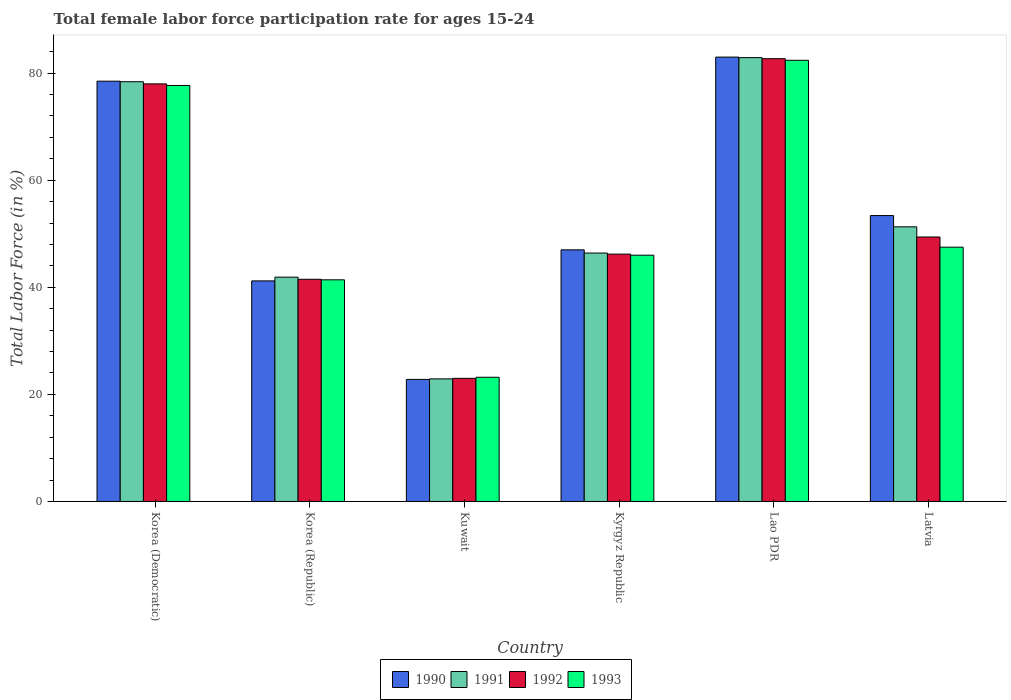How many different coloured bars are there?
Offer a terse response. 4. How many bars are there on the 2nd tick from the left?
Provide a succinct answer. 4. How many bars are there on the 1st tick from the right?
Give a very brief answer. 4. What is the label of the 3rd group of bars from the left?
Make the answer very short. Kuwait. What is the female labor force participation rate in 1991 in Korea (Republic)?
Provide a short and direct response. 41.9. Across all countries, what is the maximum female labor force participation rate in 1993?
Your answer should be compact. 82.4. Across all countries, what is the minimum female labor force participation rate in 1991?
Your answer should be compact. 22.9. In which country was the female labor force participation rate in 1990 maximum?
Make the answer very short. Lao PDR. In which country was the female labor force participation rate in 1991 minimum?
Offer a very short reply. Kuwait. What is the total female labor force participation rate in 1992 in the graph?
Provide a succinct answer. 320.8. What is the difference between the female labor force participation rate in 1991 in Kyrgyz Republic and that in Lao PDR?
Offer a terse response. -36.5. What is the difference between the female labor force participation rate in 1990 in Latvia and the female labor force participation rate in 1993 in Kuwait?
Keep it short and to the point. 30.2. What is the average female labor force participation rate in 1990 per country?
Offer a very short reply. 54.32. What is the difference between the female labor force participation rate of/in 1992 and female labor force participation rate of/in 1990 in Korea (Democratic)?
Offer a terse response. -0.5. In how many countries, is the female labor force participation rate in 1992 greater than 44 %?
Make the answer very short. 4. What is the ratio of the female labor force participation rate in 1993 in Korea (Democratic) to that in Kuwait?
Provide a succinct answer. 3.35. Is the female labor force participation rate in 1990 in Korea (Republic) less than that in Lao PDR?
Your response must be concise. Yes. Is the difference between the female labor force participation rate in 1992 in Korea (Democratic) and Kuwait greater than the difference between the female labor force participation rate in 1990 in Korea (Democratic) and Kuwait?
Provide a succinct answer. No. What is the difference between the highest and the second highest female labor force participation rate in 1991?
Provide a short and direct response. 31.6. What is the difference between the highest and the lowest female labor force participation rate in 1991?
Offer a terse response. 60. Is it the case that in every country, the sum of the female labor force participation rate in 1993 and female labor force participation rate in 1992 is greater than the sum of female labor force participation rate in 1991 and female labor force participation rate in 1990?
Keep it short and to the point. No. What does the 2nd bar from the left in Kuwait represents?
Your answer should be very brief. 1991. What does the 4th bar from the right in Kyrgyz Republic represents?
Make the answer very short. 1990. Are all the bars in the graph horizontal?
Ensure brevity in your answer.  No. What is the difference between two consecutive major ticks on the Y-axis?
Your answer should be very brief. 20. Does the graph contain any zero values?
Your answer should be compact. No. Does the graph contain grids?
Keep it short and to the point. No. Where does the legend appear in the graph?
Make the answer very short. Bottom center. How many legend labels are there?
Ensure brevity in your answer.  4. How are the legend labels stacked?
Your response must be concise. Horizontal. What is the title of the graph?
Offer a terse response. Total female labor force participation rate for ages 15-24. What is the label or title of the Y-axis?
Your response must be concise. Total Labor Force (in %). What is the Total Labor Force (in %) of 1990 in Korea (Democratic)?
Offer a terse response. 78.5. What is the Total Labor Force (in %) in 1991 in Korea (Democratic)?
Provide a short and direct response. 78.4. What is the Total Labor Force (in %) in 1993 in Korea (Democratic)?
Keep it short and to the point. 77.7. What is the Total Labor Force (in %) in 1990 in Korea (Republic)?
Provide a short and direct response. 41.2. What is the Total Labor Force (in %) of 1991 in Korea (Republic)?
Your answer should be compact. 41.9. What is the Total Labor Force (in %) of 1992 in Korea (Republic)?
Give a very brief answer. 41.5. What is the Total Labor Force (in %) in 1993 in Korea (Republic)?
Offer a very short reply. 41.4. What is the Total Labor Force (in %) of 1990 in Kuwait?
Make the answer very short. 22.8. What is the Total Labor Force (in %) of 1991 in Kuwait?
Ensure brevity in your answer.  22.9. What is the Total Labor Force (in %) of 1992 in Kuwait?
Ensure brevity in your answer.  23. What is the Total Labor Force (in %) of 1993 in Kuwait?
Provide a short and direct response. 23.2. What is the Total Labor Force (in %) in 1991 in Kyrgyz Republic?
Your response must be concise. 46.4. What is the Total Labor Force (in %) of 1992 in Kyrgyz Republic?
Keep it short and to the point. 46.2. What is the Total Labor Force (in %) of 1993 in Kyrgyz Republic?
Make the answer very short. 46. What is the Total Labor Force (in %) of 1990 in Lao PDR?
Provide a succinct answer. 83. What is the Total Labor Force (in %) of 1991 in Lao PDR?
Your response must be concise. 82.9. What is the Total Labor Force (in %) of 1992 in Lao PDR?
Your answer should be compact. 82.7. What is the Total Labor Force (in %) in 1993 in Lao PDR?
Provide a short and direct response. 82.4. What is the Total Labor Force (in %) of 1990 in Latvia?
Keep it short and to the point. 53.4. What is the Total Labor Force (in %) of 1991 in Latvia?
Your answer should be compact. 51.3. What is the Total Labor Force (in %) in 1992 in Latvia?
Your answer should be compact. 49.4. What is the Total Labor Force (in %) of 1993 in Latvia?
Provide a succinct answer. 47.5. Across all countries, what is the maximum Total Labor Force (in %) in 1991?
Offer a terse response. 82.9. Across all countries, what is the maximum Total Labor Force (in %) in 1992?
Give a very brief answer. 82.7. Across all countries, what is the maximum Total Labor Force (in %) in 1993?
Provide a short and direct response. 82.4. Across all countries, what is the minimum Total Labor Force (in %) of 1990?
Provide a short and direct response. 22.8. Across all countries, what is the minimum Total Labor Force (in %) of 1991?
Make the answer very short. 22.9. Across all countries, what is the minimum Total Labor Force (in %) of 1993?
Make the answer very short. 23.2. What is the total Total Labor Force (in %) of 1990 in the graph?
Keep it short and to the point. 325.9. What is the total Total Labor Force (in %) of 1991 in the graph?
Your answer should be very brief. 323.8. What is the total Total Labor Force (in %) of 1992 in the graph?
Your answer should be compact. 320.8. What is the total Total Labor Force (in %) in 1993 in the graph?
Your answer should be very brief. 318.2. What is the difference between the Total Labor Force (in %) in 1990 in Korea (Democratic) and that in Korea (Republic)?
Provide a short and direct response. 37.3. What is the difference between the Total Labor Force (in %) in 1991 in Korea (Democratic) and that in Korea (Republic)?
Offer a very short reply. 36.5. What is the difference between the Total Labor Force (in %) of 1992 in Korea (Democratic) and that in Korea (Republic)?
Provide a short and direct response. 36.5. What is the difference between the Total Labor Force (in %) of 1993 in Korea (Democratic) and that in Korea (Republic)?
Provide a succinct answer. 36.3. What is the difference between the Total Labor Force (in %) of 1990 in Korea (Democratic) and that in Kuwait?
Your response must be concise. 55.7. What is the difference between the Total Labor Force (in %) of 1991 in Korea (Democratic) and that in Kuwait?
Make the answer very short. 55.5. What is the difference between the Total Labor Force (in %) in 1993 in Korea (Democratic) and that in Kuwait?
Offer a terse response. 54.5. What is the difference between the Total Labor Force (in %) of 1990 in Korea (Democratic) and that in Kyrgyz Republic?
Offer a very short reply. 31.5. What is the difference between the Total Labor Force (in %) of 1992 in Korea (Democratic) and that in Kyrgyz Republic?
Give a very brief answer. 31.8. What is the difference between the Total Labor Force (in %) in 1993 in Korea (Democratic) and that in Kyrgyz Republic?
Make the answer very short. 31.7. What is the difference between the Total Labor Force (in %) in 1990 in Korea (Democratic) and that in Lao PDR?
Provide a short and direct response. -4.5. What is the difference between the Total Labor Force (in %) in 1991 in Korea (Democratic) and that in Lao PDR?
Your answer should be compact. -4.5. What is the difference between the Total Labor Force (in %) of 1990 in Korea (Democratic) and that in Latvia?
Ensure brevity in your answer.  25.1. What is the difference between the Total Labor Force (in %) of 1991 in Korea (Democratic) and that in Latvia?
Ensure brevity in your answer.  27.1. What is the difference between the Total Labor Force (in %) of 1992 in Korea (Democratic) and that in Latvia?
Keep it short and to the point. 28.6. What is the difference between the Total Labor Force (in %) in 1993 in Korea (Democratic) and that in Latvia?
Offer a terse response. 30.2. What is the difference between the Total Labor Force (in %) in 1990 in Korea (Republic) and that in Kuwait?
Your answer should be compact. 18.4. What is the difference between the Total Labor Force (in %) in 1991 in Korea (Republic) and that in Kuwait?
Offer a very short reply. 19. What is the difference between the Total Labor Force (in %) of 1992 in Korea (Republic) and that in Kuwait?
Give a very brief answer. 18.5. What is the difference between the Total Labor Force (in %) in 1990 in Korea (Republic) and that in Kyrgyz Republic?
Provide a short and direct response. -5.8. What is the difference between the Total Labor Force (in %) of 1991 in Korea (Republic) and that in Kyrgyz Republic?
Give a very brief answer. -4.5. What is the difference between the Total Labor Force (in %) in 1993 in Korea (Republic) and that in Kyrgyz Republic?
Provide a short and direct response. -4.6. What is the difference between the Total Labor Force (in %) of 1990 in Korea (Republic) and that in Lao PDR?
Provide a succinct answer. -41.8. What is the difference between the Total Labor Force (in %) in 1991 in Korea (Republic) and that in Lao PDR?
Provide a short and direct response. -41. What is the difference between the Total Labor Force (in %) of 1992 in Korea (Republic) and that in Lao PDR?
Offer a terse response. -41.2. What is the difference between the Total Labor Force (in %) of 1993 in Korea (Republic) and that in Lao PDR?
Ensure brevity in your answer.  -41. What is the difference between the Total Labor Force (in %) in 1990 in Korea (Republic) and that in Latvia?
Your response must be concise. -12.2. What is the difference between the Total Labor Force (in %) of 1991 in Korea (Republic) and that in Latvia?
Ensure brevity in your answer.  -9.4. What is the difference between the Total Labor Force (in %) of 1992 in Korea (Republic) and that in Latvia?
Your answer should be compact. -7.9. What is the difference between the Total Labor Force (in %) in 1990 in Kuwait and that in Kyrgyz Republic?
Give a very brief answer. -24.2. What is the difference between the Total Labor Force (in %) in 1991 in Kuwait and that in Kyrgyz Republic?
Ensure brevity in your answer.  -23.5. What is the difference between the Total Labor Force (in %) of 1992 in Kuwait and that in Kyrgyz Republic?
Keep it short and to the point. -23.2. What is the difference between the Total Labor Force (in %) in 1993 in Kuwait and that in Kyrgyz Republic?
Ensure brevity in your answer.  -22.8. What is the difference between the Total Labor Force (in %) in 1990 in Kuwait and that in Lao PDR?
Provide a short and direct response. -60.2. What is the difference between the Total Labor Force (in %) of 1991 in Kuwait and that in Lao PDR?
Your answer should be very brief. -60. What is the difference between the Total Labor Force (in %) in 1992 in Kuwait and that in Lao PDR?
Your answer should be very brief. -59.7. What is the difference between the Total Labor Force (in %) in 1993 in Kuwait and that in Lao PDR?
Offer a very short reply. -59.2. What is the difference between the Total Labor Force (in %) of 1990 in Kuwait and that in Latvia?
Make the answer very short. -30.6. What is the difference between the Total Labor Force (in %) in 1991 in Kuwait and that in Latvia?
Your response must be concise. -28.4. What is the difference between the Total Labor Force (in %) of 1992 in Kuwait and that in Latvia?
Ensure brevity in your answer.  -26.4. What is the difference between the Total Labor Force (in %) of 1993 in Kuwait and that in Latvia?
Provide a short and direct response. -24.3. What is the difference between the Total Labor Force (in %) of 1990 in Kyrgyz Republic and that in Lao PDR?
Your answer should be compact. -36. What is the difference between the Total Labor Force (in %) of 1991 in Kyrgyz Republic and that in Lao PDR?
Make the answer very short. -36.5. What is the difference between the Total Labor Force (in %) of 1992 in Kyrgyz Republic and that in Lao PDR?
Your answer should be compact. -36.5. What is the difference between the Total Labor Force (in %) in 1993 in Kyrgyz Republic and that in Lao PDR?
Your answer should be very brief. -36.4. What is the difference between the Total Labor Force (in %) of 1990 in Kyrgyz Republic and that in Latvia?
Give a very brief answer. -6.4. What is the difference between the Total Labor Force (in %) in 1991 in Kyrgyz Republic and that in Latvia?
Provide a succinct answer. -4.9. What is the difference between the Total Labor Force (in %) in 1992 in Kyrgyz Republic and that in Latvia?
Provide a short and direct response. -3.2. What is the difference between the Total Labor Force (in %) of 1993 in Kyrgyz Republic and that in Latvia?
Your response must be concise. -1.5. What is the difference between the Total Labor Force (in %) of 1990 in Lao PDR and that in Latvia?
Your answer should be very brief. 29.6. What is the difference between the Total Labor Force (in %) in 1991 in Lao PDR and that in Latvia?
Give a very brief answer. 31.6. What is the difference between the Total Labor Force (in %) of 1992 in Lao PDR and that in Latvia?
Your answer should be compact. 33.3. What is the difference between the Total Labor Force (in %) in 1993 in Lao PDR and that in Latvia?
Make the answer very short. 34.9. What is the difference between the Total Labor Force (in %) in 1990 in Korea (Democratic) and the Total Labor Force (in %) in 1991 in Korea (Republic)?
Make the answer very short. 36.6. What is the difference between the Total Labor Force (in %) in 1990 in Korea (Democratic) and the Total Labor Force (in %) in 1992 in Korea (Republic)?
Offer a terse response. 37. What is the difference between the Total Labor Force (in %) of 1990 in Korea (Democratic) and the Total Labor Force (in %) of 1993 in Korea (Republic)?
Your answer should be very brief. 37.1. What is the difference between the Total Labor Force (in %) in 1991 in Korea (Democratic) and the Total Labor Force (in %) in 1992 in Korea (Republic)?
Make the answer very short. 36.9. What is the difference between the Total Labor Force (in %) in 1991 in Korea (Democratic) and the Total Labor Force (in %) in 1993 in Korea (Republic)?
Your answer should be compact. 37. What is the difference between the Total Labor Force (in %) in 1992 in Korea (Democratic) and the Total Labor Force (in %) in 1993 in Korea (Republic)?
Your answer should be compact. 36.6. What is the difference between the Total Labor Force (in %) in 1990 in Korea (Democratic) and the Total Labor Force (in %) in 1991 in Kuwait?
Your response must be concise. 55.6. What is the difference between the Total Labor Force (in %) in 1990 in Korea (Democratic) and the Total Labor Force (in %) in 1992 in Kuwait?
Your answer should be very brief. 55.5. What is the difference between the Total Labor Force (in %) in 1990 in Korea (Democratic) and the Total Labor Force (in %) in 1993 in Kuwait?
Ensure brevity in your answer.  55.3. What is the difference between the Total Labor Force (in %) of 1991 in Korea (Democratic) and the Total Labor Force (in %) of 1992 in Kuwait?
Provide a succinct answer. 55.4. What is the difference between the Total Labor Force (in %) of 1991 in Korea (Democratic) and the Total Labor Force (in %) of 1993 in Kuwait?
Provide a succinct answer. 55.2. What is the difference between the Total Labor Force (in %) in 1992 in Korea (Democratic) and the Total Labor Force (in %) in 1993 in Kuwait?
Provide a succinct answer. 54.8. What is the difference between the Total Labor Force (in %) in 1990 in Korea (Democratic) and the Total Labor Force (in %) in 1991 in Kyrgyz Republic?
Make the answer very short. 32.1. What is the difference between the Total Labor Force (in %) in 1990 in Korea (Democratic) and the Total Labor Force (in %) in 1992 in Kyrgyz Republic?
Provide a short and direct response. 32.3. What is the difference between the Total Labor Force (in %) in 1990 in Korea (Democratic) and the Total Labor Force (in %) in 1993 in Kyrgyz Republic?
Ensure brevity in your answer.  32.5. What is the difference between the Total Labor Force (in %) in 1991 in Korea (Democratic) and the Total Labor Force (in %) in 1992 in Kyrgyz Republic?
Give a very brief answer. 32.2. What is the difference between the Total Labor Force (in %) in 1991 in Korea (Democratic) and the Total Labor Force (in %) in 1993 in Kyrgyz Republic?
Give a very brief answer. 32.4. What is the difference between the Total Labor Force (in %) in 1992 in Korea (Democratic) and the Total Labor Force (in %) in 1993 in Kyrgyz Republic?
Ensure brevity in your answer.  32. What is the difference between the Total Labor Force (in %) in 1990 in Korea (Democratic) and the Total Labor Force (in %) in 1991 in Lao PDR?
Make the answer very short. -4.4. What is the difference between the Total Labor Force (in %) in 1990 in Korea (Democratic) and the Total Labor Force (in %) in 1992 in Lao PDR?
Offer a very short reply. -4.2. What is the difference between the Total Labor Force (in %) of 1990 in Korea (Democratic) and the Total Labor Force (in %) of 1993 in Lao PDR?
Give a very brief answer. -3.9. What is the difference between the Total Labor Force (in %) in 1991 in Korea (Democratic) and the Total Labor Force (in %) in 1992 in Lao PDR?
Offer a terse response. -4.3. What is the difference between the Total Labor Force (in %) of 1990 in Korea (Democratic) and the Total Labor Force (in %) of 1991 in Latvia?
Keep it short and to the point. 27.2. What is the difference between the Total Labor Force (in %) in 1990 in Korea (Democratic) and the Total Labor Force (in %) in 1992 in Latvia?
Keep it short and to the point. 29.1. What is the difference between the Total Labor Force (in %) in 1991 in Korea (Democratic) and the Total Labor Force (in %) in 1992 in Latvia?
Give a very brief answer. 29. What is the difference between the Total Labor Force (in %) of 1991 in Korea (Democratic) and the Total Labor Force (in %) of 1993 in Latvia?
Provide a succinct answer. 30.9. What is the difference between the Total Labor Force (in %) of 1992 in Korea (Democratic) and the Total Labor Force (in %) of 1993 in Latvia?
Provide a succinct answer. 30.5. What is the difference between the Total Labor Force (in %) of 1990 in Korea (Republic) and the Total Labor Force (in %) of 1991 in Kuwait?
Provide a short and direct response. 18.3. What is the difference between the Total Labor Force (in %) in 1990 in Korea (Republic) and the Total Labor Force (in %) in 1992 in Kuwait?
Provide a short and direct response. 18.2. What is the difference between the Total Labor Force (in %) of 1991 in Korea (Republic) and the Total Labor Force (in %) of 1993 in Kuwait?
Ensure brevity in your answer.  18.7. What is the difference between the Total Labor Force (in %) of 1990 in Korea (Republic) and the Total Labor Force (in %) of 1993 in Kyrgyz Republic?
Offer a very short reply. -4.8. What is the difference between the Total Labor Force (in %) in 1991 in Korea (Republic) and the Total Labor Force (in %) in 1993 in Kyrgyz Republic?
Ensure brevity in your answer.  -4.1. What is the difference between the Total Labor Force (in %) in 1990 in Korea (Republic) and the Total Labor Force (in %) in 1991 in Lao PDR?
Offer a terse response. -41.7. What is the difference between the Total Labor Force (in %) in 1990 in Korea (Republic) and the Total Labor Force (in %) in 1992 in Lao PDR?
Make the answer very short. -41.5. What is the difference between the Total Labor Force (in %) of 1990 in Korea (Republic) and the Total Labor Force (in %) of 1993 in Lao PDR?
Your response must be concise. -41.2. What is the difference between the Total Labor Force (in %) in 1991 in Korea (Republic) and the Total Labor Force (in %) in 1992 in Lao PDR?
Provide a short and direct response. -40.8. What is the difference between the Total Labor Force (in %) in 1991 in Korea (Republic) and the Total Labor Force (in %) in 1993 in Lao PDR?
Offer a terse response. -40.5. What is the difference between the Total Labor Force (in %) of 1992 in Korea (Republic) and the Total Labor Force (in %) of 1993 in Lao PDR?
Provide a succinct answer. -40.9. What is the difference between the Total Labor Force (in %) of 1990 in Korea (Republic) and the Total Labor Force (in %) of 1993 in Latvia?
Offer a very short reply. -6.3. What is the difference between the Total Labor Force (in %) in 1991 in Korea (Republic) and the Total Labor Force (in %) in 1992 in Latvia?
Your response must be concise. -7.5. What is the difference between the Total Labor Force (in %) of 1991 in Korea (Republic) and the Total Labor Force (in %) of 1993 in Latvia?
Your response must be concise. -5.6. What is the difference between the Total Labor Force (in %) in 1992 in Korea (Republic) and the Total Labor Force (in %) in 1993 in Latvia?
Give a very brief answer. -6. What is the difference between the Total Labor Force (in %) of 1990 in Kuwait and the Total Labor Force (in %) of 1991 in Kyrgyz Republic?
Provide a short and direct response. -23.6. What is the difference between the Total Labor Force (in %) in 1990 in Kuwait and the Total Labor Force (in %) in 1992 in Kyrgyz Republic?
Your answer should be compact. -23.4. What is the difference between the Total Labor Force (in %) of 1990 in Kuwait and the Total Labor Force (in %) of 1993 in Kyrgyz Republic?
Ensure brevity in your answer.  -23.2. What is the difference between the Total Labor Force (in %) of 1991 in Kuwait and the Total Labor Force (in %) of 1992 in Kyrgyz Republic?
Keep it short and to the point. -23.3. What is the difference between the Total Labor Force (in %) of 1991 in Kuwait and the Total Labor Force (in %) of 1993 in Kyrgyz Republic?
Your response must be concise. -23.1. What is the difference between the Total Labor Force (in %) in 1990 in Kuwait and the Total Labor Force (in %) in 1991 in Lao PDR?
Offer a terse response. -60.1. What is the difference between the Total Labor Force (in %) in 1990 in Kuwait and the Total Labor Force (in %) in 1992 in Lao PDR?
Give a very brief answer. -59.9. What is the difference between the Total Labor Force (in %) of 1990 in Kuwait and the Total Labor Force (in %) of 1993 in Lao PDR?
Give a very brief answer. -59.6. What is the difference between the Total Labor Force (in %) in 1991 in Kuwait and the Total Labor Force (in %) in 1992 in Lao PDR?
Provide a short and direct response. -59.8. What is the difference between the Total Labor Force (in %) in 1991 in Kuwait and the Total Labor Force (in %) in 1993 in Lao PDR?
Ensure brevity in your answer.  -59.5. What is the difference between the Total Labor Force (in %) of 1992 in Kuwait and the Total Labor Force (in %) of 1993 in Lao PDR?
Make the answer very short. -59.4. What is the difference between the Total Labor Force (in %) of 1990 in Kuwait and the Total Labor Force (in %) of 1991 in Latvia?
Your answer should be very brief. -28.5. What is the difference between the Total Labor Force (in %) in 1990 in Kuwait and the Total Labor Force (in %) in 1992 in Latvia?
Your answer should be very brief. -26.6. What is the difference between the Total Labor Force (in %) in 1990 in Kuwait and the Total Labor Force (in %) in 1993 in Latvia?
Offer a terse response. -24.7. What is the difference between the Total Labor Force (in %) in 1991 in Kuwait and the Total Labor Force (in %) in 1992 in Latvia?
Your answer should be very brief. -26.5. What is the difference between the Total Labor Force (in %) of 1991 in Kuwait and the Total Labor Force (in %) of 1993 in Latvia?
Keep it short and to the point. -24.6. What is the difference between the Total Labor Force (in %) in 1992 in Kuwait and the Total Labor Force (in %) in 1993 in Latvia?
Make the answer very short. -24.5. What is the difference between the Total Labor Force (in %) of 1990 in Kyrgyz Republic and the Total Labor Force (in %) of 1991 in Lao PDR?
Provide a succinct answer. -35.9. What is the difference between the Total Labor Force (in %) in 1990 in Kyrgyz Republic and the Total Labor Force (in %) in 1992 in Lao PDR?
Provide a short and direct response. -35.7. What is the difference between the Total Labor Force (in %) of 1990 in Kyrgyz Republic and the Total Labor Force (in %) of 1993 in Lao PDR?
Provide a succinct answer. -35.4. What is the difference between the Total Labor Force (in %) in 1991 in Kyrgyz Republic and the Total Labor Force (in %) in 1992 in Lao PDR?
Offer a very short reply. -36.3. What is the difference between the Total Labor Force (in %) of 1991 in Kyrgyz Republic and the Total Labor Force (in %) of 1993 in Lao PDR?
Your response must be concise. -36. What is the difference between the Total Labor Force (in %) in 1992 in Kyrgyz Republic and the Total Labor Force (in %) in 1993 in Lao PDR?
Offer a terse response. -36.2. What is the difference between the Total Labor Force (in %) of 1990 in Kyrgyz Republic and the Total Labor Force (in %) of 1991 in Latvia?
Make the answer very short. -4.3. What is the difference between the Total Labor Force (in %) in 1990 in Kyrgyz Republic and the Total Labor Force (in %) in 1993 in Latvia?
Provide a short and direct response. -0.5. What is the difference between the Total Labor Force (in %) in 1991 in Kyrgyz Republic and the Total Labor Force (in %) in 1992 in Latvia?
Your answer should be very brief. -3. What is the difference between the Total Labor Force (in %) of 1991 in Kyrgyz Republic and the Total Labor Force (in %) of 1993 in Latvia?
Offer a terse response. -1.1. What is the difference between the Total Labor Force (in %) of 1992 in Kyrgyz Republic and the Total Labor Force (in %) of 1993 in Latvia?
Your response must be concise. -1.3. What is the difference between the Total Labor Force (in %) in 1990 in Lao PDR and the Total Labor Force (in %) in 1991 in Latvia?
Ensure brevity in your answer.  31.7. What is the difference between the Total Labor Force (in %) of 1990 in Lao PDR and the Total Labor Force (in %) of 1992 in Latvia?
Ensure brevity in your answer.  33.6. What is the difference between the Total Labor Force (in %) in 1990 in Lao PDR and the Total Labor Force (in %) in 1993 in Latvia?
Make the answer very short. 35.5. What is the difference between the Total Labor Force (in %) of 1991 in Lao PDR and the Total Labor Force (in %) of 1992 in Latvia?
Your response must be concise. 33.5. What is the difference between the Total Labor Force (in %) of 1991 in Lao PDR and the Total Labor Force (in %) of 1993 in Latvia?
Keep it short and to the point. 35.4. What is the difference between the Total Labor Force (in %) of 1992 in Lao PDR and the Total Labor Force (in %) of 1993 in Latvia?
Your answer should be very brief. 35.2. What is the average Total Labor Force (in %) in 1990 per country?
Make the answer very short. 54.32. What is the average Total Labor Force (in %) in 1991 per country?
Ensure brevity in your answer.  53.97. What is the average Total Labor Force (in %) of 1992 per country?
Provide a succinct answer. 53.47. What is the average Total Labor Force (in %) in 1993 per country?
Ensure brevity in your answer.  53.03. What is the difference between the Total Labor Force (in %) in 1990 and Total Labor Force (in %) in 1992 in Korea (Democratic)?
Your answer should be very brief. 0.5. What is the difference between the Total Labor Force (in %) in 1991 and Total Labor Force (in %) in 1993 in Korea (Democratic)?
Offer a very short reply. 0.7. What is the difference between the Total Labor Force (in %) of 1992 and Total Labor Force (in %) of 1993 in Korea (Democratic)?
Give a very brief answer. 0.3. What is the difference between the Total Labor Force (in %) of 1990 and Total Labor Force (in %) of 1993 in Korea (Republic)?
Offer a very short reply. -0.2. What is the difference between the Total Labor Force (in %) in 1991 and Total Labor Force (in %) in 1993 in Korea (Republic)?
Offer a terse response. 0.5. What is the difference between the Total Labor Force (in %) of 1990 and Total Labor Force (in %) of 1992 in Kuwait?
Offer a terse response. -0.2. What is the difference between the Total Labor Force (in %) in 1990 and Total Labor Force (in %) in 1993 in Kuwait?
Give a very brief answer. -0.4. What is the difference between the Total Labor Force (in %) of 1991 and Total Labor Force (in %) of 1992 in Kuwait?
Give a very brief answer. -0.1. What is the difference between the Total Labor Force (in %) of 1991 and Total Labor Force (in %) of 1993 in Kuwait?
Your answer should be compact. -0.3. What is the difference between the Total Labor Force (in %) in 1992 and Total Labor Force (in %) in 1993 in Kuwait?
Offer a terse response. -0.2. What is the difference between the Total Labor Force (in %) in 1990 and Total Labor Force (in %) in 1993 in Kyrgyz Republic?
Provide a short and direct response. 1. What is the difference between the Total Labor Force (in %) in 1991 and Total Labor Force (in %) in 1993 in Kyrgyz Republic?
Ensure brevity in your answer.  0.4. What is the difference between the Total Labor Force (in %) of 1990 and Total Labor Force (in %) of 1991 in Lao PDR?
Give a very brief answer. 0.1. What is the difference between the Total Labor Force (in %) of 1990 and Total Labor Force (in %) of 1993 in Lao PDR?
Your answer should be very brief. 0.6. What is the difference between the Total Labor Force (in %) of 1991 and Total Labor Force (in %) of 1993 in Lao PDR?
Your response must be concise. 0.5. What is the difference between the Total Labor Force (in %) in 1990 and Total Labor Force (in %) in 1991 in Latvia?
Ensure brevity in your answer.  2.1. What is the difference between the Total Labor Force (in %) of 1990 and Total Labor Force (in %) of 1992 in Latvia?
Offer a very short reply. 4. What is the difference between the Total Labor Force (in %) of 1990 and Total Labor Force (in %) of 1993 in Latvia?
Ensure brevity in your answer.  5.9. What is the difference between the Total Labor Force (in %) of 1991 and Total Labor Force (in %) of 1993 in Latvia?
Keep it short and to the point. 3.8. What is the ratio of the Total Labor Force (in %) in 1990 in Korea (Democratic) to that in Korea (Republic)?
Offer a terse response. 1.91. What is the ratio of the Total Labor Force (in %) of 1991 in Korea (Democratic) to that in Korea (Republic)?
Give a very brief answer. 1.87. What is the ratio of the Total Labor Force (in %) of 1992 in Korea (Democratic) to that in Korea (Republic)?
Offer a terse response. 1.88. What is the ratio of the Total Labor Force (in %) of 1993 in Korea (Democratic) to that in Korea (Republic)?
Provide a short and direct response. 1.88. What is the ratio of the Total Labor Force (in %) of 1990 in Korea (Democratic) to that in Kuwait?
Keep it short and to the point. 3.44. What is the ratio of the Total Labor Force (in %) in 1991 in Korea (Democratic) to that in Kuwait?
Give a very brief answer. 3.42. What is the ratio of the Total Labor Force (in %) of 1992 in Korea (Democratic) to that in Kuwait?
Make the answer very short. 3.39. What is the ratio of the Total Labor Force (in %) in 1993 in Korea (Democratic) to that in Kuwait?
Offer a terse response. 3.35. What is the ratio of the Total Labor Force (in %) in 1990 in Korea (Democratic) to that in Kyrgyz Republic?
Offer a very short reply. 1.67. What is the ratio of the Total Labor Force (in %) in 1991 in Korea (Democratic) to that in Kyrgyz Republic?
Your answer should be compact. 1.69. What is the ratio of the Total Labor Force (in %) in 1992 in Korea (Democratic) to that in Kyrgyz Republic?
Your response must be concise. 1.69. What is the ratio of the Total Labor Force (in %) of 1993 in Korea (Democratic) to that in Kyrgyz Republic?
Provide a succinct answer. 1.69. What is the ratio of the Total Labor Force (in %) of 1990 in Korea (Democratic) to that in Lao PDR?
Provide a succinct answer. 0.95. What is the ratio of the Total Labor Force (in %) of 1991 in Korea (Democratic) to that in Lao PDR?
Ensure brevity in your answer.  0.95. What is the ratio of the Total Labor Force (in %) of 1992 in Korea (Democratic) to that in Lao PDR?
Provide a short and direct response. 0.94. What is the ratio of the Total Labor Force (in %) in 1993 in Korea (Democratic) to that in Lao PDR?
Keep it short and to the point. 0.94. What is the ratio of the Total Labor Force (in %) of 1990 in Korea (Democratic) to that in Latvia?
Offer a very short reply. 1.47. What is the ratio of the Total Labor Force (in %) of 1991 in Korea (Democratic) to that in Latvia?
Make the answer very short. 1.53. What is the ratio of the Total Labor Force (in %) of 1992 in Korea (Democratic) to that in Latvia?
Offer a terse response. 1.58. What is the ratio of the Total Labor Force (in %) in 1993 in Korea (Democratic) to that in Latvia?
Your answer should be very brief. 1.64. What is the ratio of the Total Labor Force (in %) of 1990 in Korea (Republic) to that in Kuwait?
Offer a very short reply. 1.81. What is the ratio of the Total Labor Force (in %) of 1991 in Korea (Republic) to that in Kuwait?
Keep it short and to the point. 1.83. What is the ratio of the Total Labor Force (in %) in 1992 in Korea (Republic) to that in Kuwait?
Offer a very short reply. 1.8. What is the ratio of the Total Labor Force (in %) in 1993 in Korea (Republic) to that in Kuwait?
Provide a succinct answer. 1.78. What is the ratio of the Total Labor Force (in %) of 1990 in Korea (Republic) to that in Kyrgyz Republic?
Offer a terse response. 0.88. What is the ratio of the Total Labor Force (in %) of 1991 in Korea (Republic) to that in Kyrgyz Republic?
Provide a succinct answer. 0.9. What is the ratio of the Total Labor Force (in %) of 1992 in Korea (Republic) to that in Kyrgyz Republic?
Your answer should be compact. 0.9. What is the ratio of the Total Labor Force (in %) in 1993 in Korea (Republic) to that in Kyrgyz Republic?
Your answer should be very brief. 0.9. What is the ratio of the Total Labor Force (in %) of 1990 in Korea (Republic) to that in Lao PDR?
Give a very brief answer. 0.5. What is the ratio of the Total Labor Force (in %) of 1991 in Korea (Republic) to that in Lao PDR?
Your answer should be very brief. 0.51. What is the ratio of the Total Labor Force (in %) in 1992 in Korea (Republic) to that in Lao PDR?
Make the answer very short. 0.5. What is the ratio of the Total Labor Force (in %) in 1993 in Korea (Republic) to that in Lao PDR?
Provide a succinct answer. 0.5. What is the ratio of the Total Labor Force (in %) in 1990 in Korea (Republic) to that in Latvia?
Keep it short and to the point. 0.77. What is the ratio of the Total Labor Force (in %) of 1991 in Korea (Republic) to that in Latvia?
Keep it short and to the point. 0.82. What is the ratio of the Total Labor Force (in %) of 1992 in Korea (Republic) to that in Latvia?
Make the answer very short. 0.84. What is the ratio of the Total Labor Force (in %) of 1993 in Korea (Republic) to that in Latvia?
Your answer should be very brief. 0.87. What is the ratio of the Total Labor Force (in %) of 1990 in Kuwait to that in Kyrgyz Republic?
Give a very brief answer. 0.49. What is the ratio of the Total Labor Force (in %) in 1991 in Kuwait to that in Kyrgyz Republic?
Provide a short and direct response. 0.49. What is the ratio of the Total Labor Force (in %) in 1992 in Kuwait to that in Kyrgyz Republic?
Provide a succinct answer. 0.5. What is the ratio of the Total Labor Force (in %) in 1993 in Kuwait to that in Kyrgyz Republic?
Give a very brief answer. 0.5. What is the ratio of the Total Labor Force (in %) in 1990 in Kuwait to that in Lao PDR?
Your response must be concise. 0.27. What is the ratio of the Total Labor Force (in %) in 1991 in Kuwait to that in Lao PDR?
Offer a terse response. 0.28. What is the ratio of the Total Labor Force (in %) of 1992 in Kuwait to that in Lao PDR?
Offer a terse response. 0.28. What is the ratio of the Total Labor Force (in %) of 1993 in Kuwait to that in Lao PDR?
Provide a short and direct response. 0.28. What is the ratio of the Total Labor Force (in %) in 1990 in Kuwait to that in Latvia?
Your answer should be very brief. 0.43. What is the ratio of the Total Labor Force (in %) of 1991 in Kuwait to that in Latvia?
Provide a succinct answer. 0.45. What is the ratio of the Total Labor Force (in %) in 1992 in Kuwait to that in Latvia?
Offer a terse response. 0.47. What is the ratio of the Total Labor Force (in %) of 1993 in Kuwait to that in Latvia?
Keep it short and to the point. 0.49. What is the ratio of the Total Labor Force (in %) of 1990 in Kyrgyz Republic to that in Lao PDR?
Offer a terse response. 0.57. What is the ratio of the Total Labor Force (in %) of 1991 in Kyrgyz Republic to that in Lao PDR?
Make the answer very short. 0.56. What is the ratio of the Total Labor Force (in %) of 1992 in Kyrgyz Republic to that in Lao PDR?
Your answer should be compact. 0.56. What is the ratio of the Total Labor Force (in %) in 1993 in Kyrgyz Republic to that in Lao PDR?
Ensure brevity in your answer.  0.56. What is the ratio of the Total Labor Force (in %) of 1990 in Kyrgyz Republic to that in Latvia?
Your answer should be compact. 0.88. What is the ratio of the Total Labor Force (in %) of 1991 in Kyrgyz Republic to that in Latvia?
Provide a succinct answer. 0.9. What is the ratio of the Total Labor Force (in %) in 1992 in Kyrgyz Republic to that in Latvia?
Provide a succinct answer. 0.94. What is the ratio of the Total Labor Force (in %) in 1993 in Kyrgyz Republic to that in Latvia?
Your response must be concise. 0.97. What is the ratio of the Total Labor Force (in %) of 1990 in Lao PDR to that in Latvia?
Your response must be concise. 1.55. What is the ratio of the Total Labor Force (in %) of 1991 in Lao PDR to that in Latvia?
Offer a very short reply. 1.62. What is the ratio of the Total Labor Force (in %) in 1992 in Lao PDR to that in Latvia?
Give a very brief answer. 1.67. What is the ratio of the Total Labor Force (in %) in 1993 in Lao PDR to that in Latvia?
Your answer should be compact. 1.73. What is the difference between the highest and the second highest Total Labor Force (in %) of 1993?
Give a very brief answer. 4.7. What is the difference between the highest and the lowest Total Labor Force (in %) of 1990?
Make the answer very short. 60.2. What is the difference between the highest and the lowest Total Labor Force (in %) of 1992?
Make the answer very short. 59.7. What is the difference between the highest and the lowest Total Labor Force (in %) of 1993?
Provide a succinct answer. 59.2. 